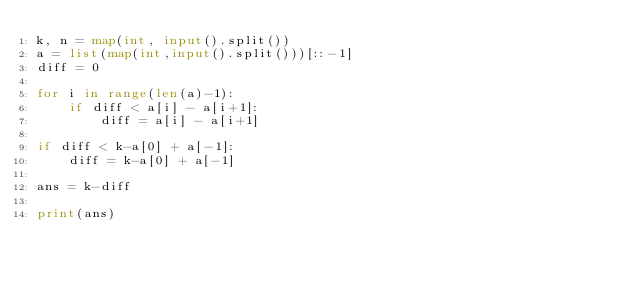<code> <loc_0><loc_0><loc_500><loc_500><_Python_>k, n = map(int, input().split())
a = list(map(int,input().split()))[::-1]
diff = 0

for i in range(len(a)-1):
    if diff < a[i] - a[i+1]:
        diff = a[i] - a[i+1]

if diff < k-a[0] + a[-1]:
    diff = k-a[0] + a[-1]

ans = k-diff

print(ans)
</code> 